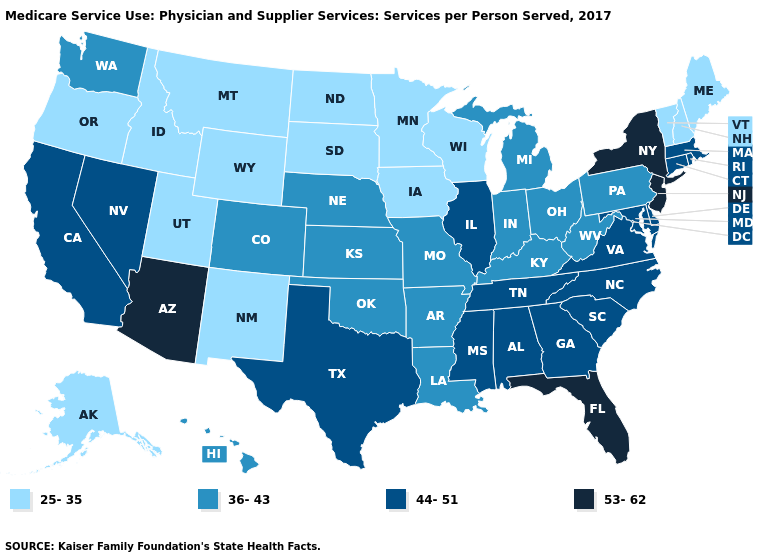Which states hav the highest value in the West?
Quick response, please. Arizona. Name the states that have a value in the range 36-43?
Concise answer only. Arkansas, Colorado, Hawaii, Indiana, Kansas, Kentucky, Louisiana, Michigan, Missouri, Nebraska, Ohio, Oklahoma, Pennsylvania, Washington, West Virginia. What is the highest value in the USA?
Quick response, please. 53-62. What is the value of Connecticut?
Quick response, please. 44-51. Among the states that border Colorado , does Arizona have the highest value?
Give a very brief answer. Yes. Name the states that have a value in the range 44-51?
Write a very short answer. Alabama, California, Connecticut, Delaware, Georgia, Illinois, Maryland, Massachusetts, Mississippi, Nevada, North Carolina, Rhode Island, South Carolina, Tennessee, Texas, Virginia. What is the highest value in the MidWest ?
Quick response, please. 44-51. Name the states that have a value in the range 53-62?
Be succinct. Arizona, Florida, New Jersey, New York. Name the states that have a value in the range 44-51?
Answer briefly. Alabama, California, Connecticut, Delaware, Georgia, Illinois, Maryland, Massachusetts, Mississippi, Nevada, North Carolina, Rhode Island, South Carolina, Tennessee, Texas, Virginia. Does the first symbol in the legend represent the smallest category?
Short answer required. Yes. How many symbols are there in the legend?
Quick response, please. 4. Name the states that have a value in the range 36-43?
Answer briefly. Arkansas, Colorado, Hawaii, Indiana, Kansas, Kentucky, Louisiana, Michigan, Missouri, Nebraska, Ohio, Oklahoma, Pennsylvania, Washington, West Virginia. What is the value of Massachusetts?
Be succinct. 44-51. What is the lowest value in states that border Vermont?
Write a very short answer. 25-35. Does South Carolina have the highest value in the South?
Short answer required. No. 